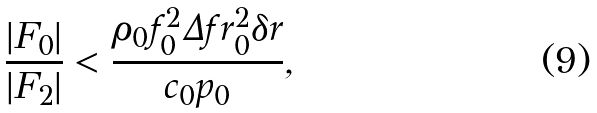<formula> <loc_0><loc_0><loc_500><loc_500>\frac { | F _ { 0 } | } { | F _ { 2 } | } < \frac { \rho _ { 0 } f _ { 0 } ^ { 2 } \Delta f r _ { 0 } ^ { 2 } \delta r } { c _ { 0 } p _ { 0 } } ,</formula> 